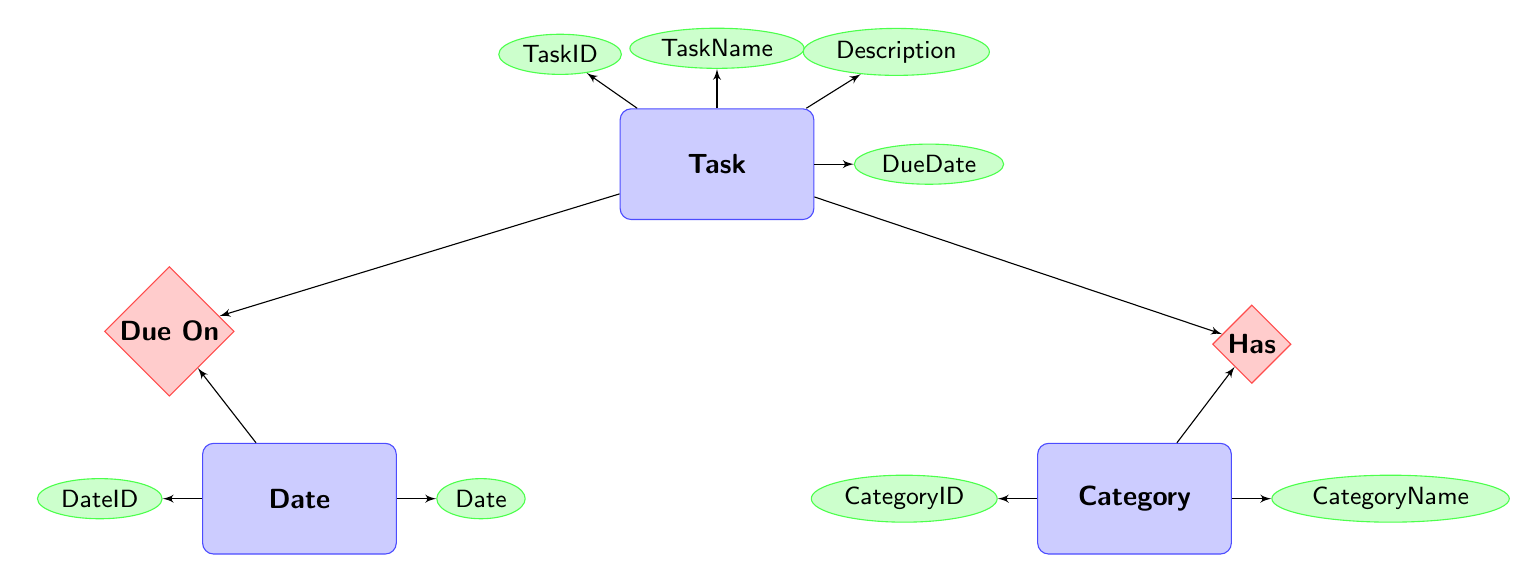What are the attributes of the Task entity? The Task entity has four attributes: TaskID, TaskName, Description, and DueDate. These attributes are displayed as ellipses connected to the Task rectangle.
Answer: TaskID, TaskName, Description, DueDate How many entities are present in the diagram? There are three entities in the diagram: Task, Category, and Date. Each is represented as a rectangle.
Answer: 3 What relationship connects Task to Category? The relationship that connects Task to Category is labeled "Has". It is represented as a diamond shape with lines connecting the Task and Category entities.
Answer: Has What is the attribute of the Date entity? The Date entity has two attributes: DateID and Date, showing the fields contained within this entity. The attributes are connected to the Date rectangle as ellipses.
Answer: DateID, Date Which entity has a relationship labeled "Due On"? The entity connected to the "Due On" relationship is the Task entity. This relationship connects Task to the Date entity, indicating when tasks are due.
Answer: Task What does the arrow direction tell you about the relationship between Task and Category? The arrow direction indicates that a Task "Has" a Category, meaning each Task belongs to a specific Category. This gives a one-to-many relationship where many Tasks can relate to a single Category.
Answer: Task "Has" Category How many attributes does the Category entity have? The Category entity has two attributes: CategoryID and CategoryName. These represent the basic information for categorizing tasks.
Answer: 2 Which entity has a connection through DueDate? The connection through DueDate involves the Task entity, as it links tasks to their specific due dates via the relationship labeled "Due On".
Answer: Task Explain how a Task is related to its specific Date. A Task is related to its specific Date through the relationship labeled "Due On", which indicates that each Task has a specified due date. This is shown by the lines connecting the Task and Date entities to the relationship.
Answer: Due On 